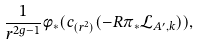Convert formula to latex. <formula><loc_0><loc_0><loc_500><loc_500>\frac { 1 } { r ^ { 2 g - 1 } } \phi _ { * } ( c _ { ( r ^ { 2 } ) } ( - R \pi _ { * } \mathcal { L } _ { A ^ { \prime } , k } ) ) ,</formula> 